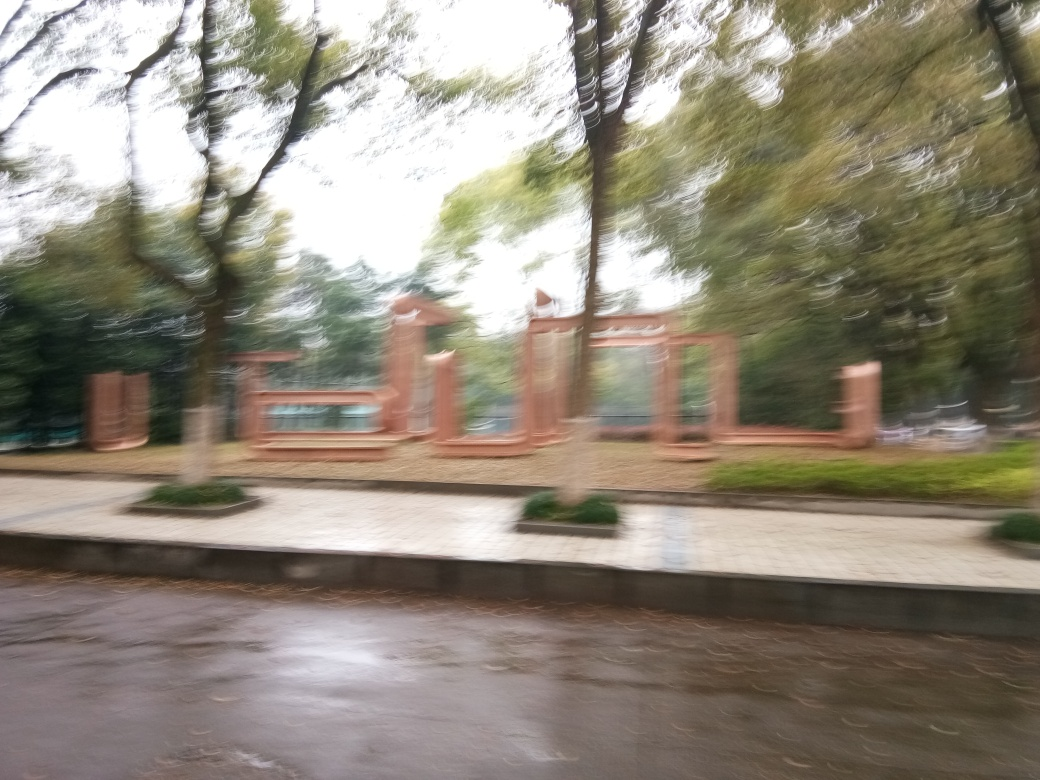Can you describe the setting or location seen in this image? While the image is quite blurry, it seems to depict an outdoor scene, possibly a park or garden area with walkways and what might be benches or structures for seating, surrounded by trees. 